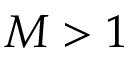Convert formula to latex. <formula><loc_0><loc_0><loc_500><loc_500>M > 1</formula> 